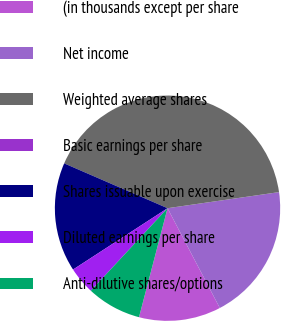Convert chart to OTSL. <chart><loc_0><loc_0><loc_500><loc_500><pie_chart><fcel>(in thousands except per share<fcel>Net income<fcel>Weighted average shares<fcel>Basic earnings per share<fcel>Shares issuable upon exercise<fcel>Diluted earnings per share<fcel>Anti-dilutive shares/options<nl><fcel>11.76%<fcel>19.6%<fcel>41.21%<fcel>0.0%<fcel>15.68%<fcel>3.92%<fcel>7.84%<nl></chart> 